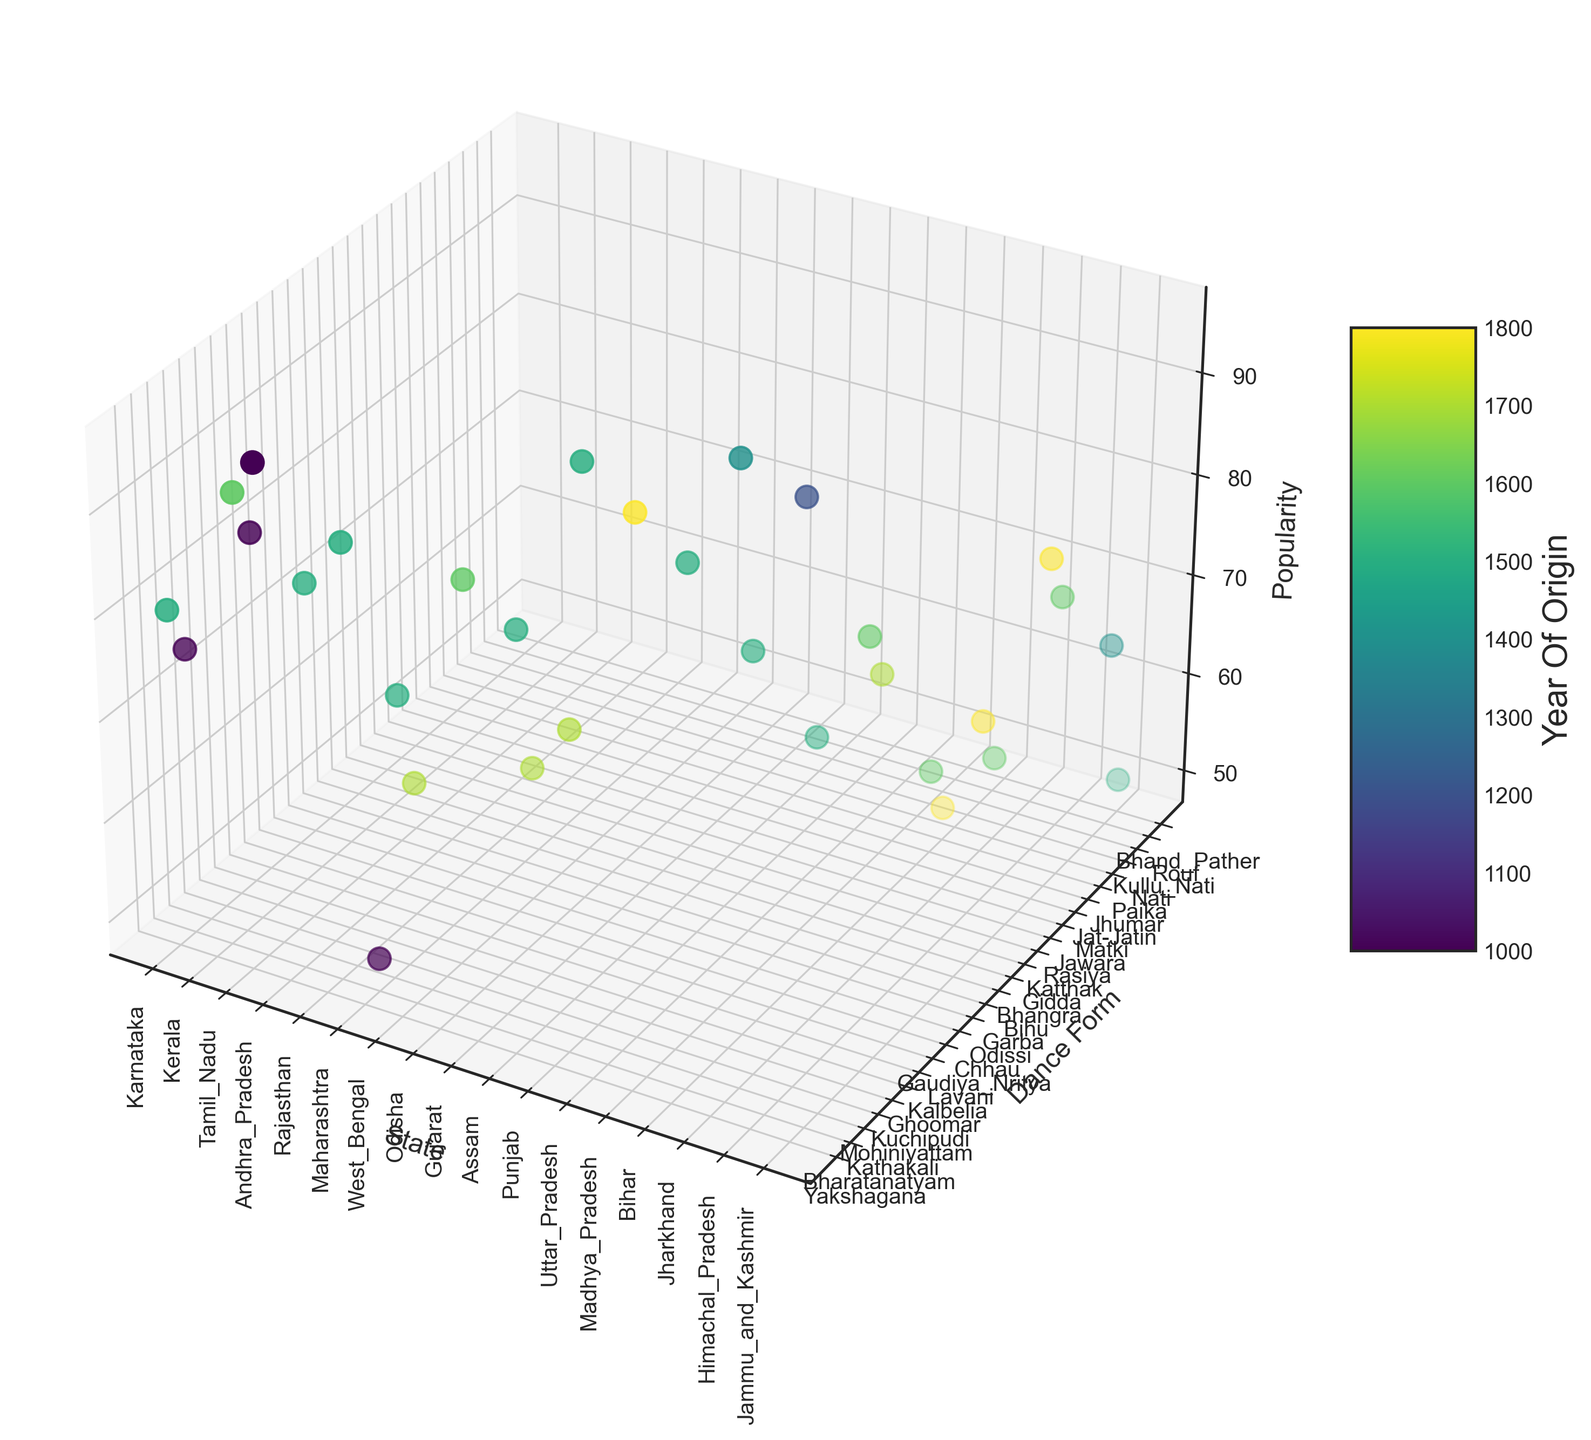What's the most popular dance form in Karnataka? Observe the z-axis (Popularity) values for dance forms in Karnataka. Yakshagana has a popularity of 80 and Bharatanatyam has a popularity of 75. Since 80 > 75, Yakshagana is the most popular.
Answer: Yakshagana Which state has the most dance forms originated around 1500? Check the color shade corresponding to the Year_of_Origin circa 1500 for different states. By comparing, Karnataka, Tamil Nadu, Andhra Pradesh, Rajasthan, West Bengal, Odisha, Assam, and Punjab have dance forms originated around 1500. Counting these, West Bengal has 2, while others have only 1 (exceptions are Bihar, Jharkhand, and Madhya Pradesh which also have more dance forms around that year, but with fewer in comparison).
Answer: West Bengal Which dance form from Kerala is most popular? Compare the z-axis (Popularity) values for Kathakali and Mohiniyattam in Kerala. Kathakali has a popularity of 90 and Mohiniyattam has 85. Since 90 > 85, Kathakali is the most popular.
Answer: Kathakali What is the average popularity of dance forms originating from 1600 across all states? Identify and list the dance forms with a Year_of_Origin of 1600. Calculate the average of their Popularity values. Here are the values: Kathakali (90), Lavani (80), Jawara (70), Bihu (80), Kullu Nati (70), Bhand Pather (50). Sum = 440. Count = 6. Average = 440/6 = 73.33.
Answer: 73.33 Compare the popularity of Kathakali and Lavani Look at the z-axis (Popularity) values for Kathakali and Lavani. Kathakali has a popularity of 90 and Lavani has a popularity of 80, so Kathakali is more popular.
Answer: Kathakali is more popular Which has a longer history, Garba or Gidda? Check the colors on the plot corresponding to the Year_of_Origin. Garba has a Year_of_Origin of 1800 and Gidda has 1500. Since 1500 < 1800, Gidda has a longer history.
Answer: Gidda What is the popularity difference between Bharatanatyam in Tamil Nadu and Maharashtra? Find Bharatanatyam in both Tamil Nadu and Maharashtra. Tamil Nadu’s Bharatanatyam has a popularity of 95 and Maharashtra’s Bharatanatyam has 50. The difference is 95 - 50 = 45.
Answer: 45 Are older dance forms generally more popular in this plot? Visually inspecting, some older dance forms (e.g., Kathakali from 1600, Bharatanatyam from 1000 in Tamil Nadu) have high popularity, but not consistently, as newer forms (e.g., Garba from 1800) can also be popular.
Answer: Not necessarily What is the least popular dance form from Bihar? Compare the z-axis (Popularity) values for Jat-Jatin (55) and Jhumar (50) in Bihar. Jhumar has the lower popularity.
Answer: Jhumar 